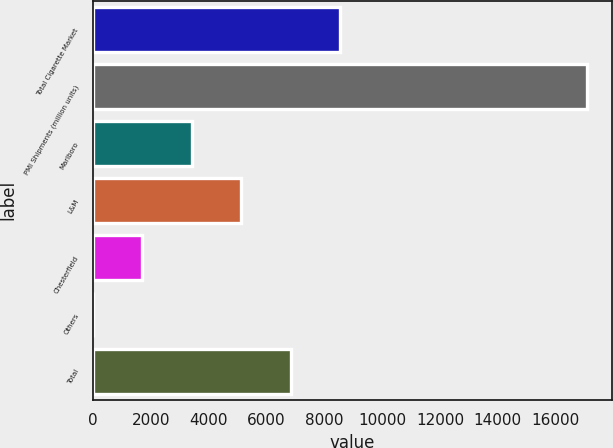Convert chart. <chart><loc_0><loc_0><loc_500><loc_500><bar_chart><fcel>Total Cigarette Market<fcel>PMI Shipments (million units)<fcel>Marlboro<fcel>L&M<fcel>Chesterfield<fcel>Others<fcel>Total<nl><fcel>8541.15<fcel>17079<fcel>3418.44<fcel>5126.01<fcel>1710.87<fcel>3.3<fcel>6833.58<nl></chart> 